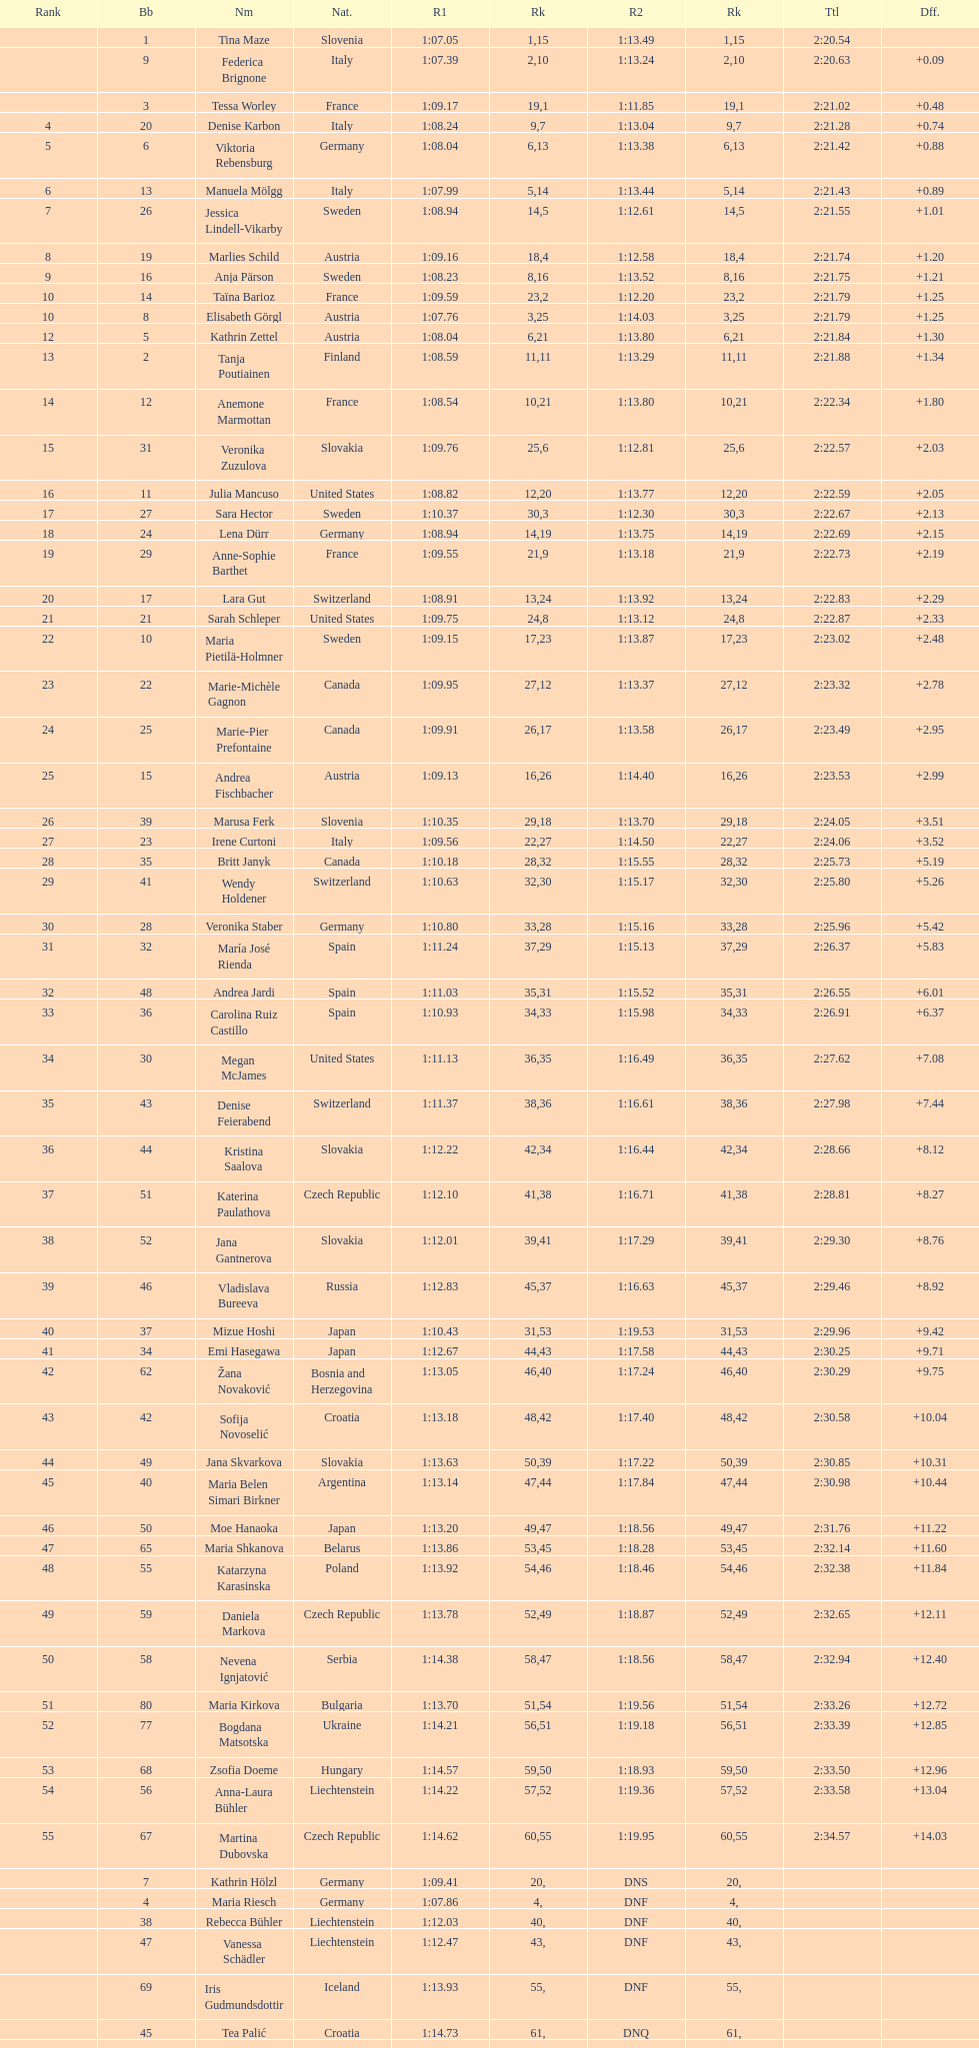What is the last country to receive a ranking? Czech Republic. 